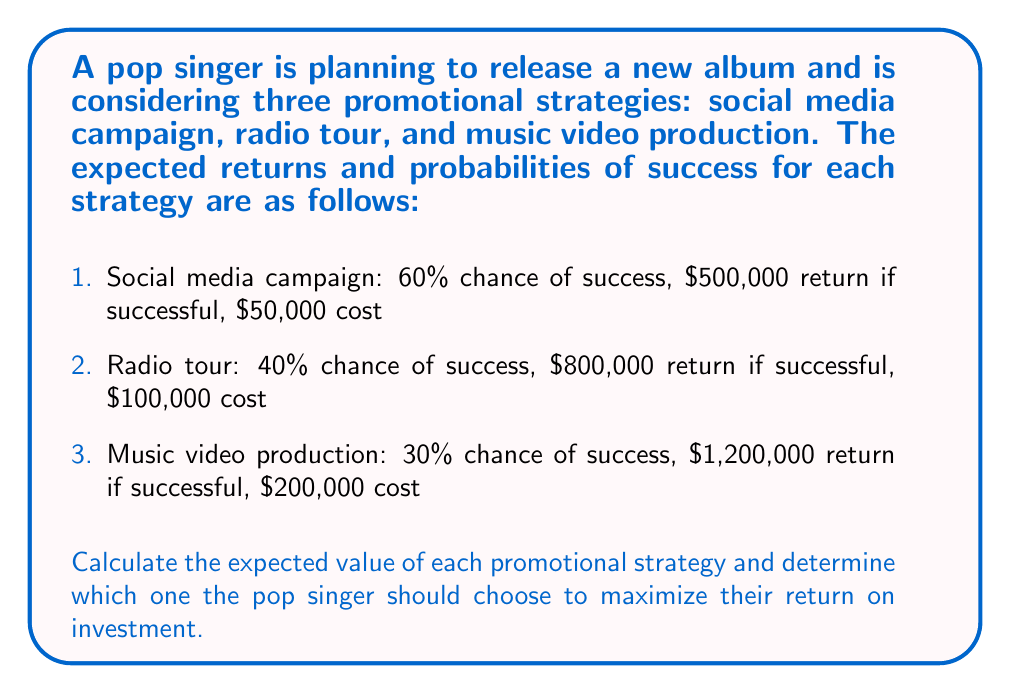Teach me how to tackle this problem. To solve this problem, we need to calculate the expected value for each promotional strategy using the formula:

$$ E(X) = (P_{success} \times R_{success}) + (P_{failure} \times R_{failure}) - C $$

Where:
$E(X)$ is the expected value
$P_{success}$ is the probability of success
$R_{success}$ is the return if successful
$P_{failure}$ is the probability of failure (1 - $P_{success}$)
$R_{failure}$ is the return if failed (0 in this case)
$C$ is the cost of the strategy

Let's calculate the expected value for each strategy:

1. Social media campaign:
$$ E(X_{social}) = (0.60 \times 500,000) + (0.40 \times 0) - 50,000 = 250,000 $$

2. Radio tour:
$$ E(X_{radio}) = (0.40 \times 800,000) + (0.60 \times 0) - 100,000 = 220,000 $$

3. Music video production:
$$ E(X_{video}) = (0.30 \times 1,200,000) + (0.70 \times 0) - 200,000 = 160,000 $$

Comparing the expected values:
$E(X_{social}) > E(X_{radio}) > E(X_{video})$
Answer: The expected values for each promotional strategy are:
1. Social media campaign: $250,000
2. Radio tour: $220,000
3. Music video production: $160,000

The pop singer should choose the social media campaign strategy as it has the highest expected value of $250,000, maximizing their return on investment. 